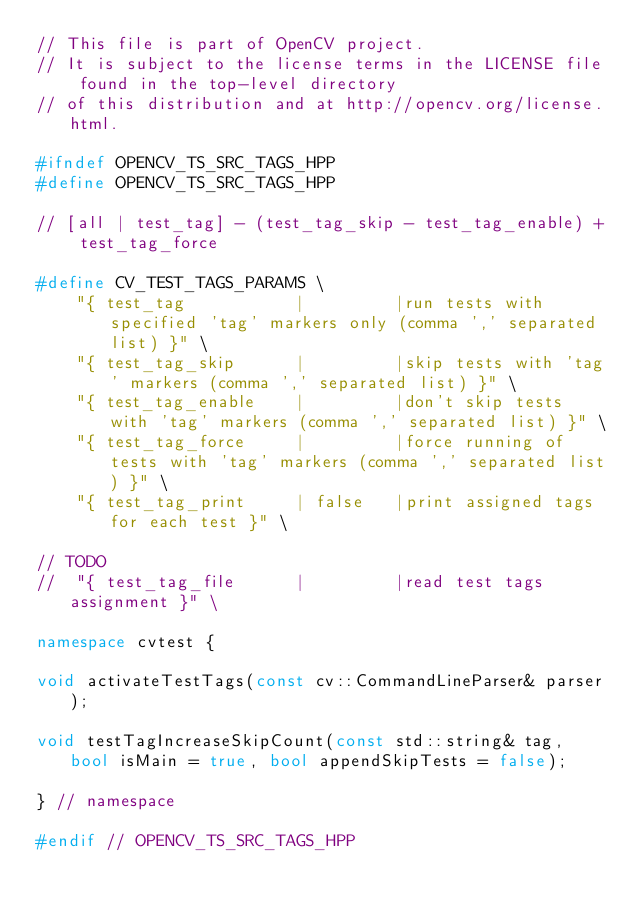Convert code to text. <code><loc_0><loc_0><loc_500><loc_500><_C++_>// This file is part of OpenCV project.
// It is subject to the license terms in the LICENSE file found in the top-level directory
// of this distribution and at http://opencv.org/license.html.

#ifndef OPENCV_TS_SRC_TAGS_HPP
#define OPENCV_TS_SRC_TAGS_HPP

// [all | test_tag] - (test_tag_skip - test_tag_enable) + test_tag_force

#define CV_TEST_TAGS_PARAMS \
    "{ test_tag           |         |run tests with specified 'tag' markers only (comma ',' separated list) }" \
    "{ test_tag_skip      |         |skip tests with 'tag' markers (comma ',' separated list) }" \
    "{ test_tag_enable    |         |don't skip tests with 'tag' markers (comma ',' separated list) }" \
    "{ test_tag_force     |         |force running of tests with 'tag' markers (comma ',' separated list) }" \
    "{ test_tag_print     | false   |print assigned tags for each test }" \

// TODO
//  "{ test_tag_file      |         |read test tags assignment }" \

namespace cvtest {

void activateTestTags(const cv::CommandLineParser& parser);

void testTagIncreaseSkipCount(const std::string& tag, bool isMain = true, bool appendSkipTests = false);

} // namespace

#endif // OPENCV_TS_SRC_TAGS_HPP
</code> 